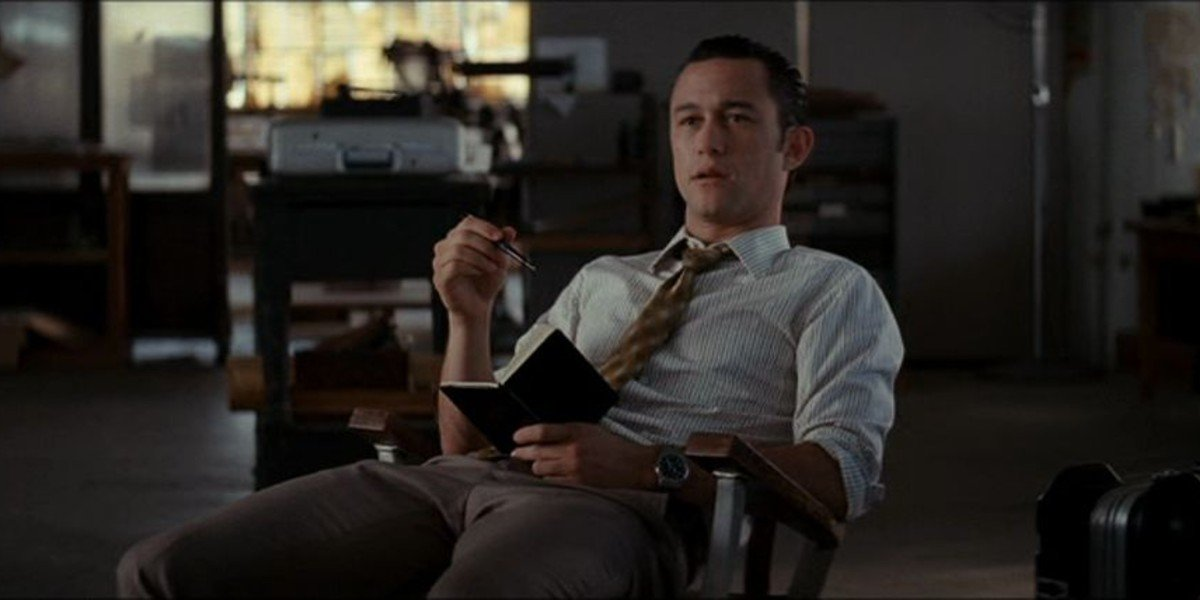Imagine this man writing an important message to his future self. What would it be? "Dear Future Me, remember this moment – the quiet pause in the midst of chaos. Stay true to your values and trust your instincts. The decisions you make now will shape not only your career but the lives of many. Keep pushing boundaries, stay humble, and always learn from each experience. Best, Your Past Self." 